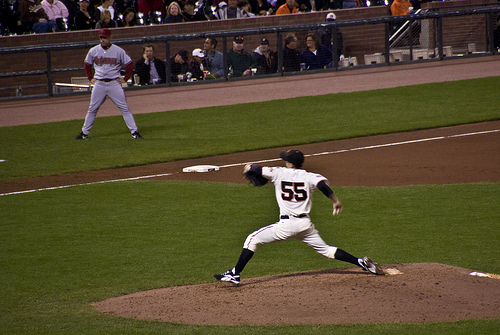What might the coach be thinking as he watches the game unfold? As the coach watches the game unfold, he might be thinking about the strategies he's drilled into his players, assessing the pitcher’s form and the fielders' positions. He is likely considering potential adjustments to make for the next inning to keep the team's lead. His mind is focused on winning but also on motivating his team, ensuring they stay engaged and energized throughout the game. 